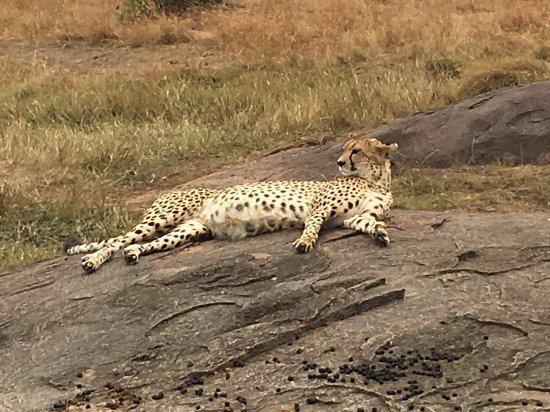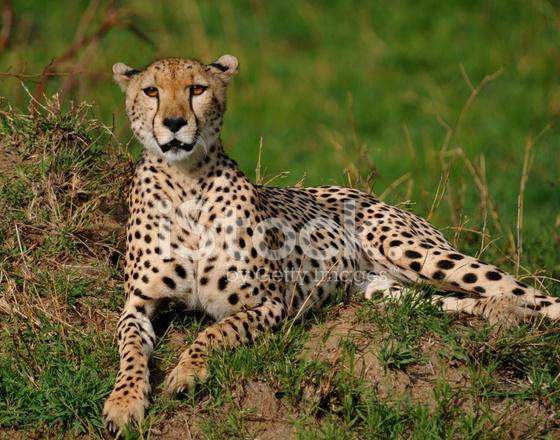The first image is the image on the left, the second image is the image on the right. Assess this claim about the two images: "Each image includes an adult cheetah reclining on the ground with its head raised.". Correct or not? Answer yes or no. Yes. The first image is the image on the left, the second image is the image on the right. For the images displayed, is the sentence "All of the cheetahs are lying down." factually correct? Answer yes or no. Yes. 